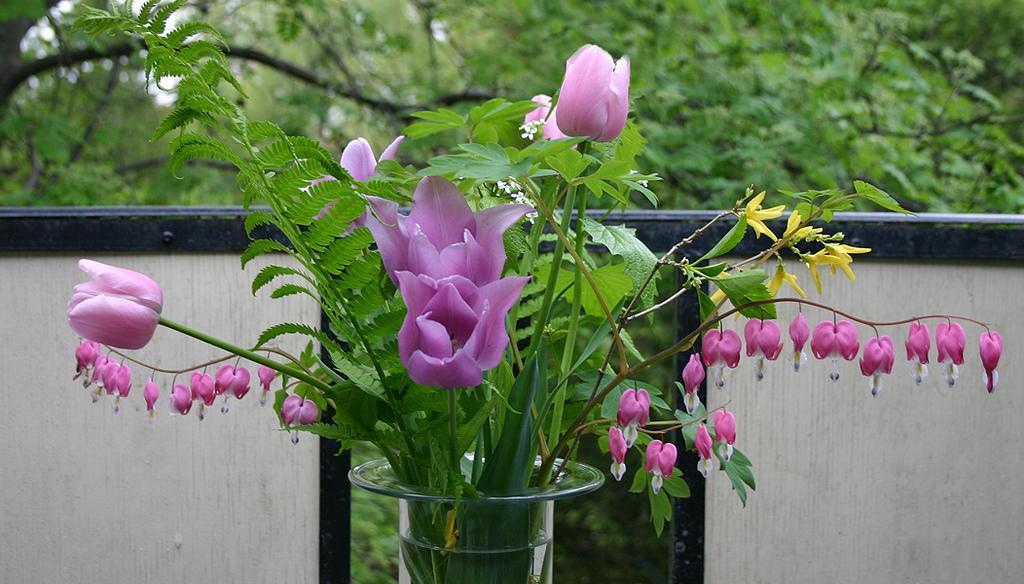In one or two sentences, can you explain what this image depicts? In this image we can see purple color flowers and plants in the vase. The background of the image is blurred, where we can see the wall and trees. 